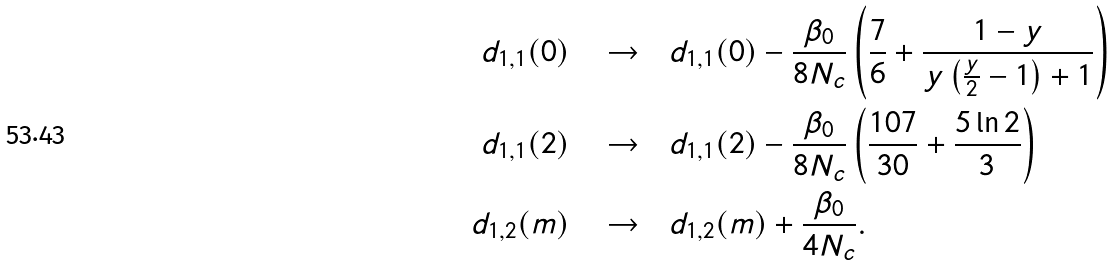Convert formula to latex. <formula><loc_0><loc_0><loc_500><loc_500>d _ { 1 , 1 } ( 0 ) \quad \rightarrow \quad & d _ { 1 , 1 } ( 0 ) - \frac { \beta _ { 0 } } { 8 N _ { c } } \left ( \frac { 7 } { 6 } + \frac { 1 - y } { y \left ( \frac { y } { 2 } - 1 \right ) + 1 } \right ) \\ d _ { 1 , 1 } ( 2 ) \quad \rightarrow \quad & d _ { 1 , 1 } ( 2 ) - \frac { \beta _ { 0 } } { 8 N _ { c } } \left ( \frac { 1 0 7 } { 3 0 } + \frac { 5 \ln 2 } { 3 } \right ) \\ d _ { 1 , 2 } ( m ) \quad \rightarrow \quad & d _ { 1 , 2 } ( m ) + \frac { \beta _ { 0 } } { 4 N _ { c } } .</formula> 